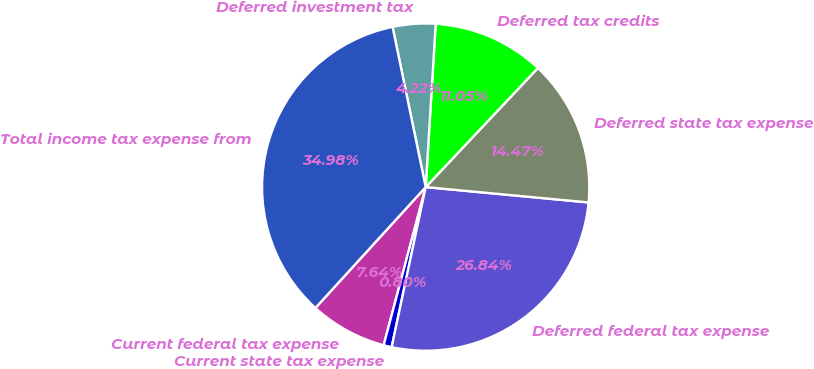Convert chart to OTSL. <chart><loc_0><loc_0><loc_500><loc_500><pie_chart><fcel>Current federal tax expense<fcel>Current state tax expense<fcel>Deferred federal tax expense<fcel>Deferred state tax expense<fcel>Deferred tax credits<fcel>Deferred investment tax<fcel>Total income tax expense from<nl><fcel>7.64%<fcel>0.8%<fcel>26.84%<fcel>14.47%<fcel>11.05%<fcel>4.22%<fcel>34.98%<nl></chart> 